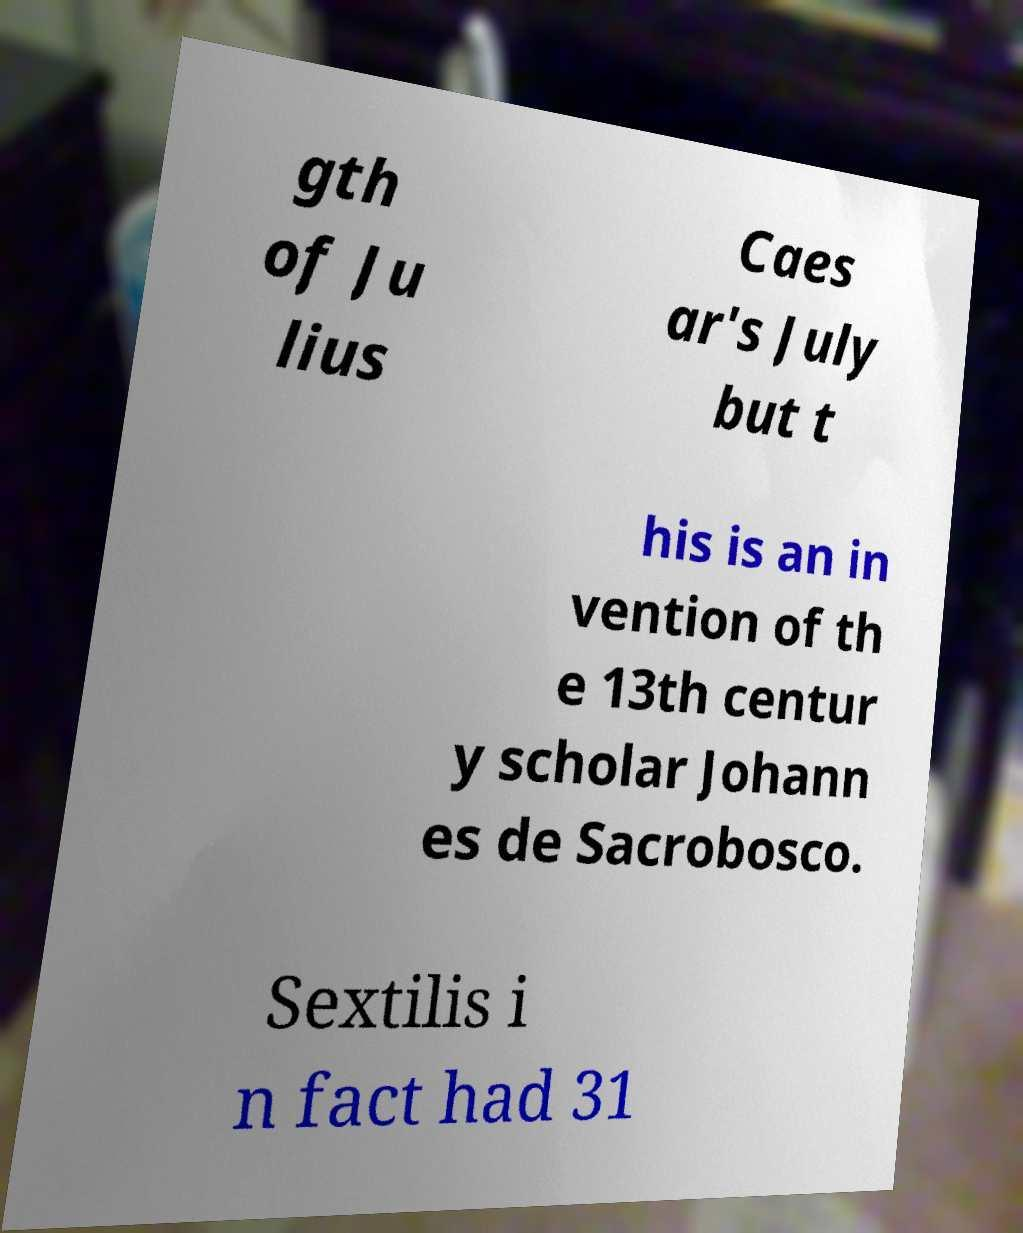I need the written content from this picture converted into text. Can you do that? gth of Ju lius Caes ar's July but t his is an in vention of th e 13th centur y scholar Johann es de Sacrobosco. Sextilis i n fact had 31 